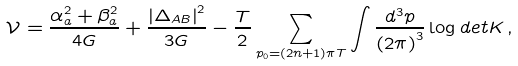Convert formula to latex. <formula><loc_0><loc_0><loc_500><loc_500>\mathcal { V } = \frac { \alpha _ { a } ^ { 2 } + \beta _ { a } ^ { 2 } } { 4 G } + \frac { \left | \Delta _ { A B } \right | ^ { 2 } } { 3 G } - \frac { T } { 2 } \sum _ { p _ { 0 } = ( 2 n + 1 ) \pi T } \int \frac { d ^ { 3 } p } { \left ( 2 \pi \right ) ^ { 3 } } \log d e t K \, ,</formula> 